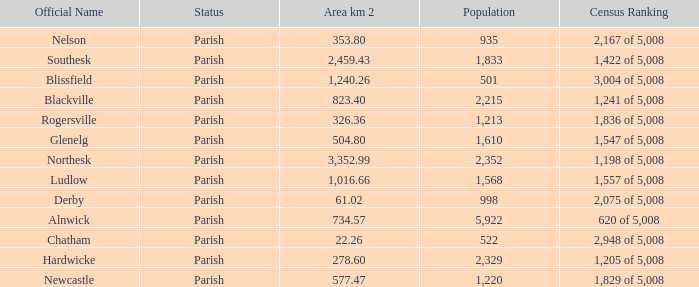Can you tell me the lowest Area km 2 that has the Population of 2,352? 3352.99. 